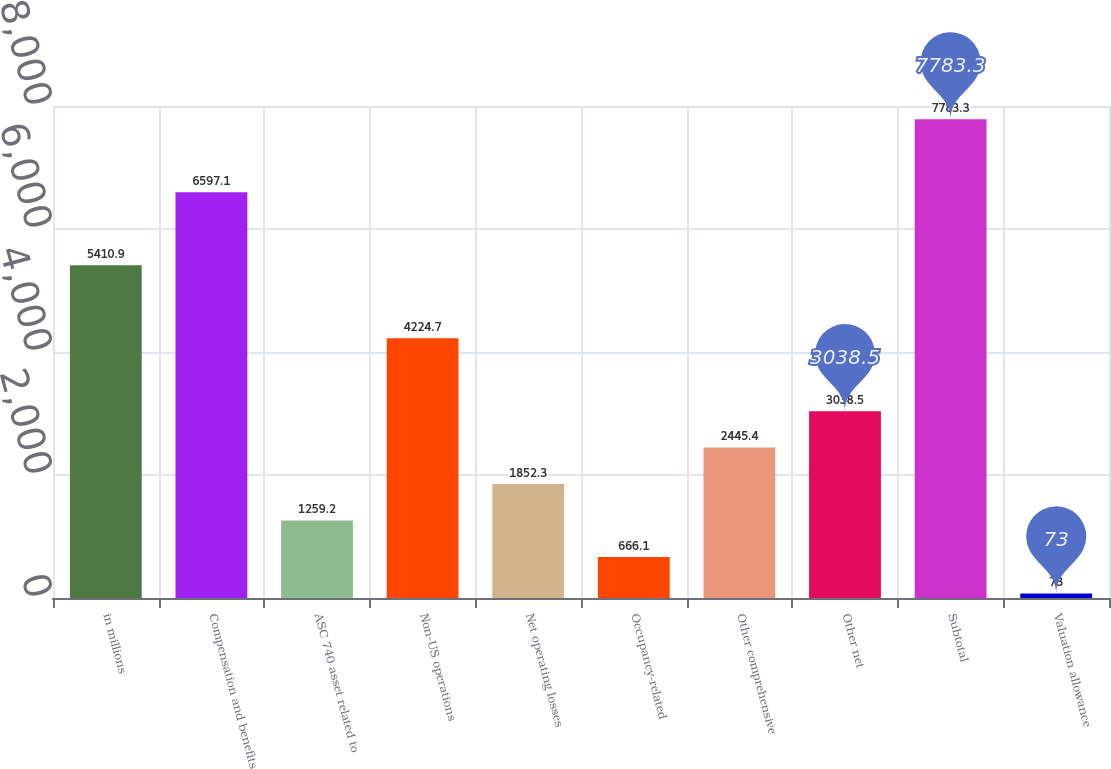Convert chart. <chart><loc_0><loc_0><loc_500><loc_500><bar_chart><fcel>in millions<fcel>Compensation and benefits<fcel>ASC 740 asset related to<fcel>Non-US operations<fcel>Net operating losses<fcel>Occupancy-related<fcel>Other comprehensive<fcel>Other net<fcel>Subtotal<fcel>Valuation allowance<nl><fcel>5410.9<fcel>6597.1<fcel>1259.2<fcel>4224.7<fcel>1852.3<fcel>666.1<fcel>2445.4<fcel>3038.5<fcel>7783.3<fcel>73<nl></chart> 